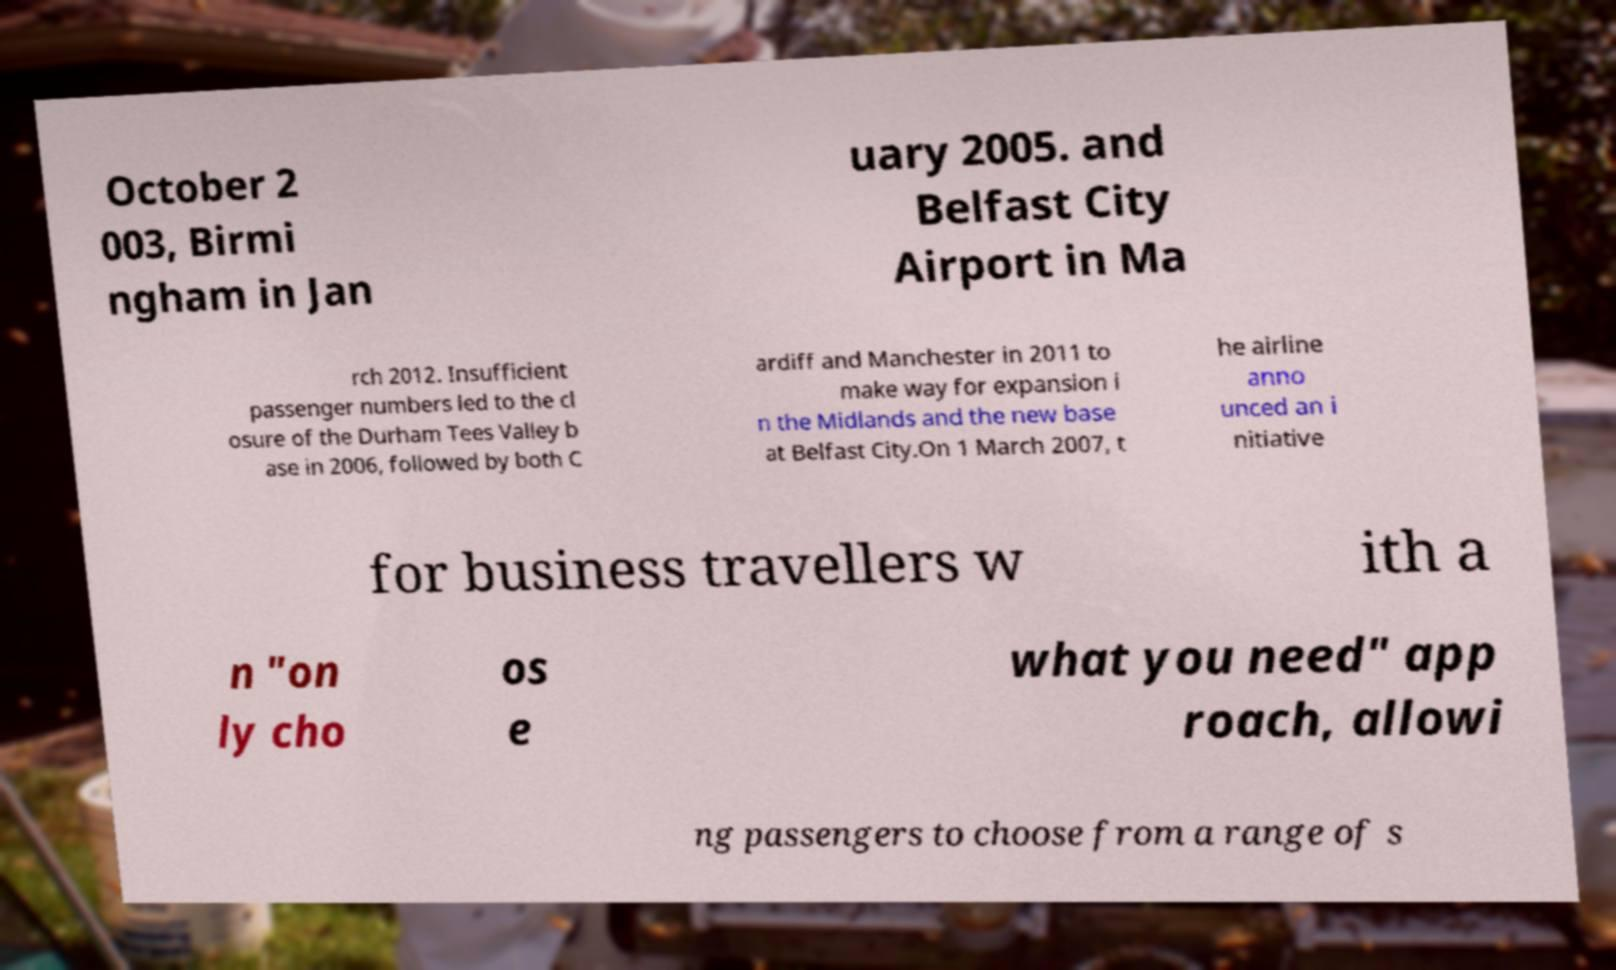I need the written content from this picture converted into text. Can you do that? October 2 003, Birmi ngham in Jan uary 2005. and Belfast City Airport in Ma rch 2012. Insufficient passenger numbers led to the cl osure of the Durham Tees Valley b ase in 2006, followed by both C ardiff and Manchester in 2011 to make way for expansion i n the Midlands and the new base at Belfast City.On 1 March 2007, t he airline anno unced an i nitiative for business travellers w ith a n "on ly cho os e what you need" app roach, allowi ng passengers to choose from a range of s 